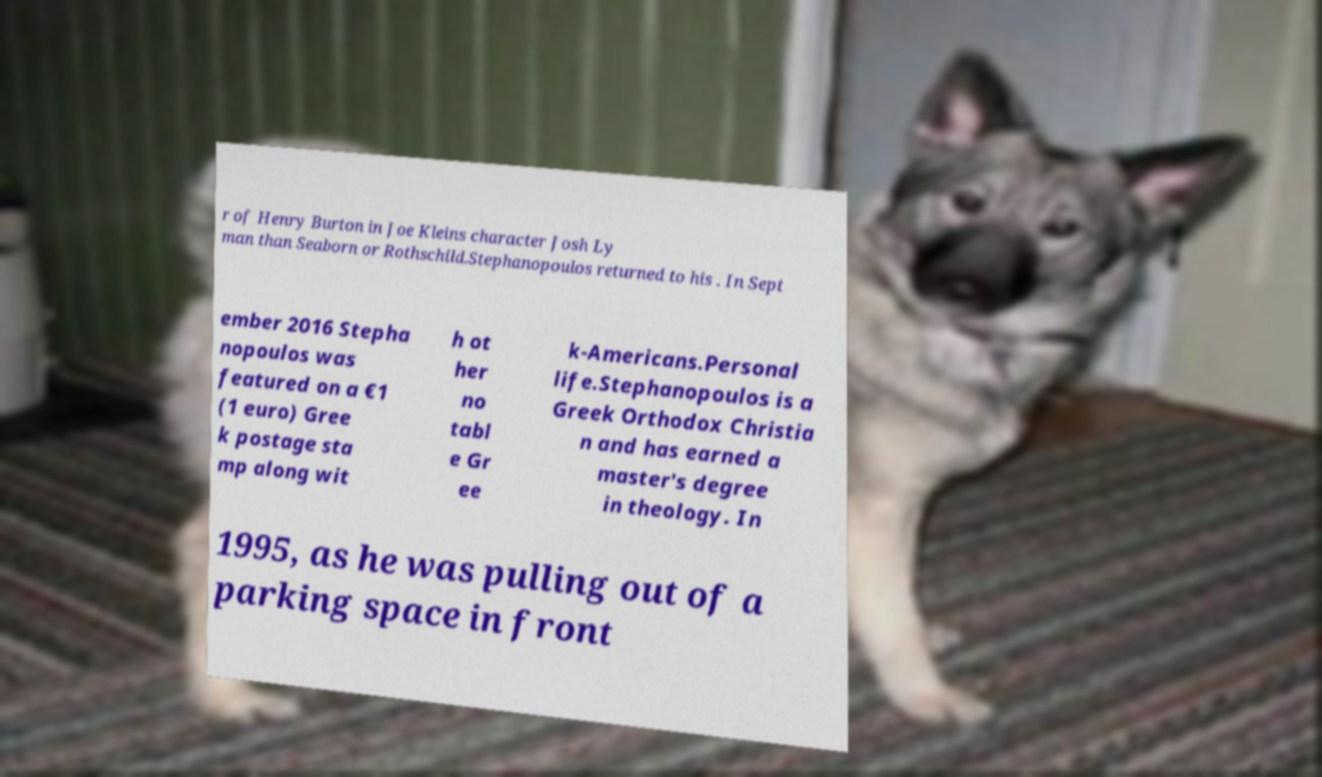I need the written content from this picture converted into text. Can you do that? r of Henry Burton in Joe Kleins character Josh Ly man than Seaborn or Rothschild.Stephanopoulos returned to his . In Sept ember 2016 Stepha nopoulos was featured on a €1 (1 euro) Gree k postage sta mp along wit h ot her no tabl e Gr ee k-Americans.Personal life.Stephanopoulos is a Greek Orthodox Christia n and has earned a master's degree in theology. In 1995, as he was pulling out of a parking space in front 